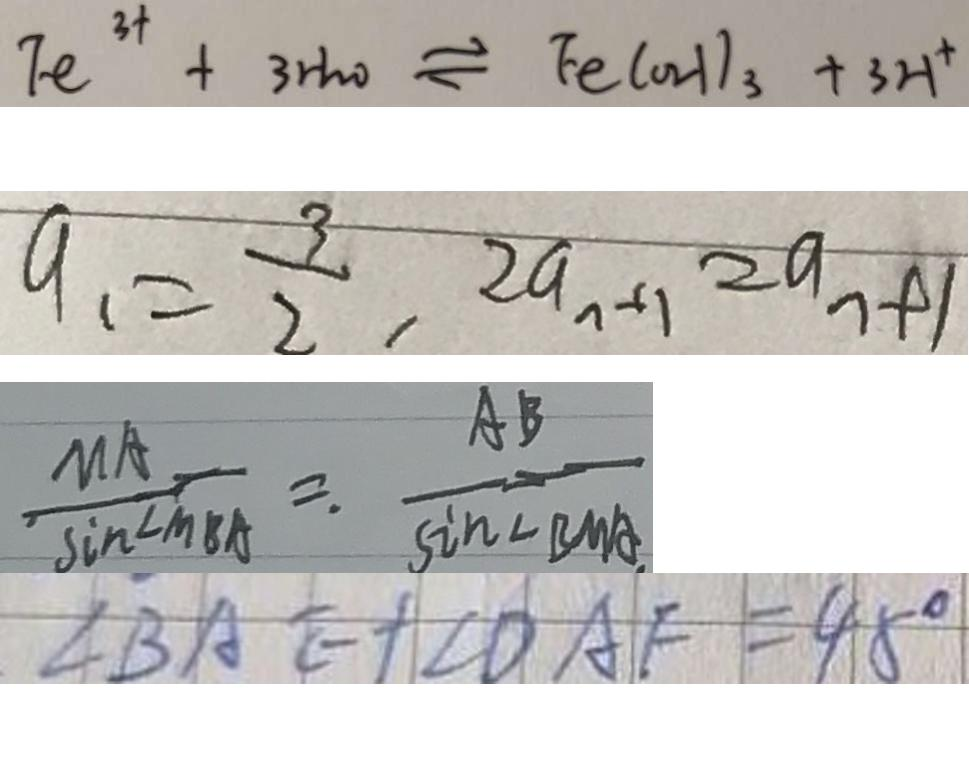<formula> <loc_0><loc_0><loc_500><loc_500>F e ^ { 3 + } + 3 H _ { 2 } O \rightleftharpoons F e ( O H ) _ { 3 } + 3 H ^ { + } 
 a _ { 1 } = \frac { 3 } { 2 } , 2 a _ { n + 1 } = a _ { n + 1 } 
 \frac { M A } { \sin \angle M B A } = \frac { A B } { \sin \angle B M A } 
 \angle B A E + \angle D A F = 4 5 ^ { \circ }</formula> 